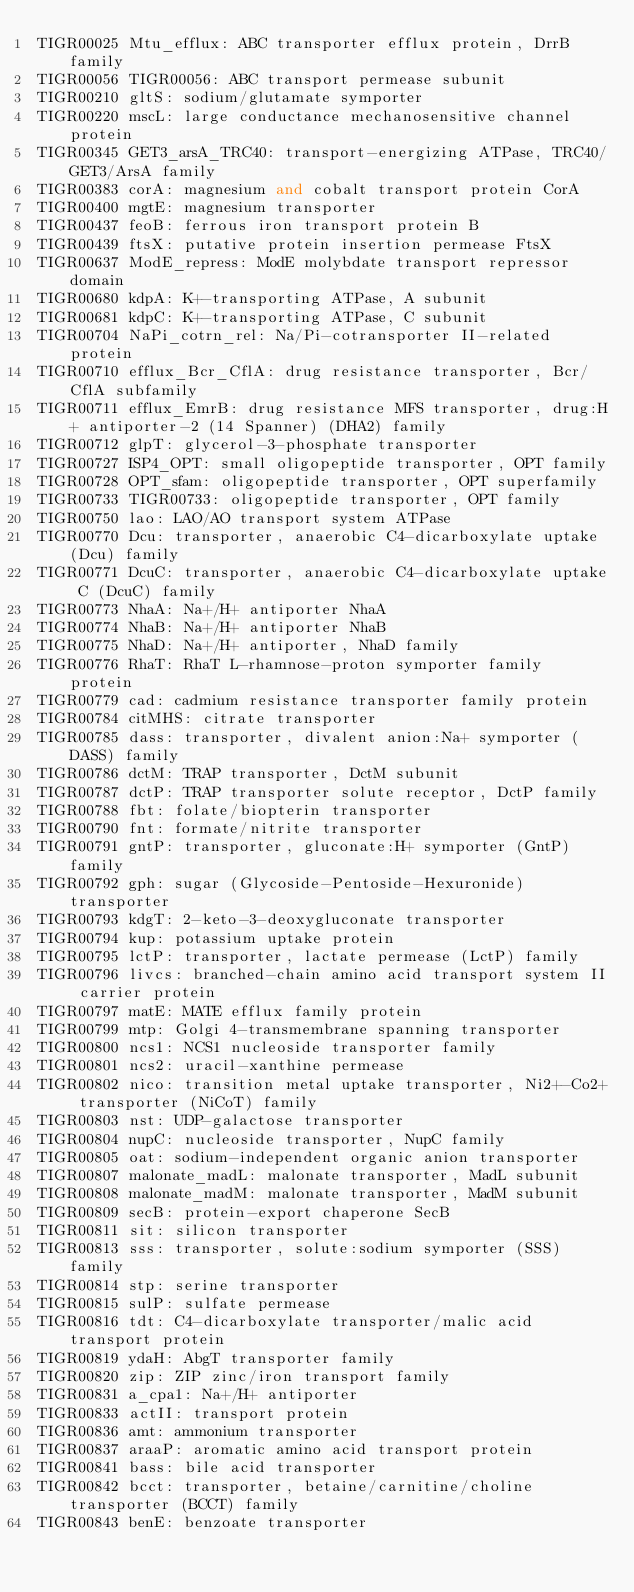<code> <loc_0><loc_0><loc_500><loc_500><_SQL_>TIGR00025	Mtu_efflux: ABC transporter efflux protein, DrrB family
TIGR00056	TIGR00056: ABC transport permease subunit
TIGR00210	gltS: sodium/glutamate symporter
TIGR00220	mscL: large conductance mechanosensitive channel protein
TIGR00345	GET3_arsA_TRC40: transport-energizing ATPase, TRC40/GET3/ArsA family
TIGR00383	corA: magnesium and cobalt transport protein CorA
TIGR00400	mgtE: magnesium transporter
TIGR00437	feoB: ferrous iron transport protein B
TIGR00439	ftsX: putative protein insertion permease FtsX
TIGR00637	ModE_repress: ModE molybdate transport repressor domain
TIGR00680	kdpA: K+-transporting ATPase, A subunit
TIGR00681	kdpC: K+-transporting ATPase, C subunit
TIGR00704	NaPi_cotrn_rel: Na/Pi-cotransporter II-related protein
TIGR00710	efflux_Bcr_CflA: drug resistance transporter, Bcr/CflA subfamily
TIGR00711	efflux_EmrB: drug resistance MFS transporter, drug:H+ antiporter-2 (14 Spanner) (DHA2) family
TIGR00712	glpT: glycerol-3-phosphate transporter
TIGR00727	ISP4_OPT: small oligopeptide transporter, OPT family
TIGR00728	OPT_sfam: oligopeptide transporter, OPT superfamily
TIGR00733	TIGR00733: oligopeptide transporter, OPT family
TIGR00750	lao: LAO/AO transport system ATPase
TIGR00770	Dcu: transporter, anaerobic C4-dicarboxylate uptake (Dcu) family
TIGR00771	DcuC: transporter, anaerobic C4-dicarboxylate uptake C (DcuC) family
TIGR00773	NhaA: Na+/H+ antiporter NhaA
TIGR00774	NhaB: Na+/H+ antiporter NhaB
TIGR00775	NhaD: Na+/H+ antiporter, NhaD family
TIGR00776	RhaT: RhaT L-rhamnose-proton symporter family protein
TIGR00779	cad: cadmium resistance transporter family protein
TIGR00784	citMHS: citrate transporter
TIGR00785	dass: transporter, divalent anion:Na+ symporter (DASS) family
TIGR00786	dctM: TRAP transporter, DctM subunit
TIGR00787	dctP: TRAP transporter solute receptor, DctP family
TIGR00788	fbt: folate/biopterin transporter
TIGR00790	fnt: formate/nitrite transporter
TIGR00791	gntP: transporter, gluconate:H+ symporter (GntP) family
TIGR00792	gph: sugar (Glycoside-Pentoside-Hexuronide) transporter
TIGR00793	kdgT: 2-keto-3-deoxygluconate transporter
TIGR00794	kup: potassium uptake protein
TIGR00795	lctP: transporter, lactate permease (LctP) family
TIGR00796	livcs: branched-chain amino acid transport system II carrier protein
TIGR00797	matE: MATE efflux family protein
TIGR00799	mtp: Golgi 4-transmembrane spanning transporter
TIGR00800	ncs1: NCS1 nucleoside transporter family
TIGR00801	ncs2: uracil-xanthine permease
TIGR00802	nico: transition metal uptake transporter, Ni2+-Co2+ transporter (NiCoT) family
TIGR00803	nst: UDP-galactose transporter
TIGR00804	nupC: nucleoside transporter, NupC family
TIGR00805	oat: sodium-independent organic anion transporter
TIGR00807	malonate_madL: malonate transporter, MadL subunit
TIGR00808	malonate_madM: malonate transporter, MadM subunit
TIGR00809	secB: protein-export chaperone SecB
TIGR00811	sit: silicon transporter
TIGR00813	sss: transporter, solute:sodium symporter (SSS) family
TIGR00814	stp: serine transporter
TIGR00815	sulP: sulfate permease
TIGR00816	tdt: C4-dicarboxylate transporter/malic acid transport protein
TIGR00819	ydaH: AbgT transporter family
TIGR00820	zip: ZIP zinc/iron transport family
TIGR00831	a_cpa1: Na+/H+ antiporter
TIGR00833	actII: transport protein
TIGR00836	amt: ammonium transporter
TIGR00837	araaP: aromatic amino acid transport protein
TIGR00841	bass: bile acid transporter
TIGR00842	bcct: transporter, betaine/carnitine/choline transporter (BCCT) family
TIGR00843	benE: benzoate transporter</code> 